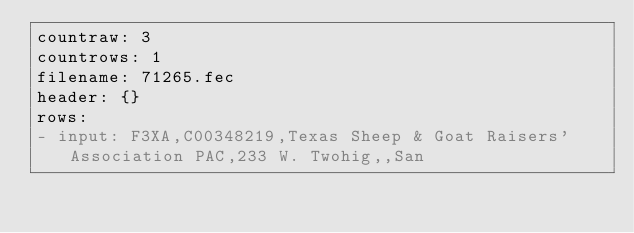<code> <loc_0><loc_0><loc_500><loc_500><_YAML_>countraw: 3
countrows: 1
filename: 71265.fec
header: {}
rows:
- input: F3XA,C00348219,Texas Sheep & Goat Raisers' Association PAC,233 W. Twohig,,San</code> 